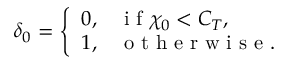Convert formula to latex. <formula><loc_0><loc_0><loc_500><loc_500>\delta _ { 0 } = \left \{ \begin{array} { l l } { 0 , } & { i f \chi _ { 0 } < C _ { T } , } \\ { 1 , } & { o t h e r w i s e . } \end{array}</formula> 